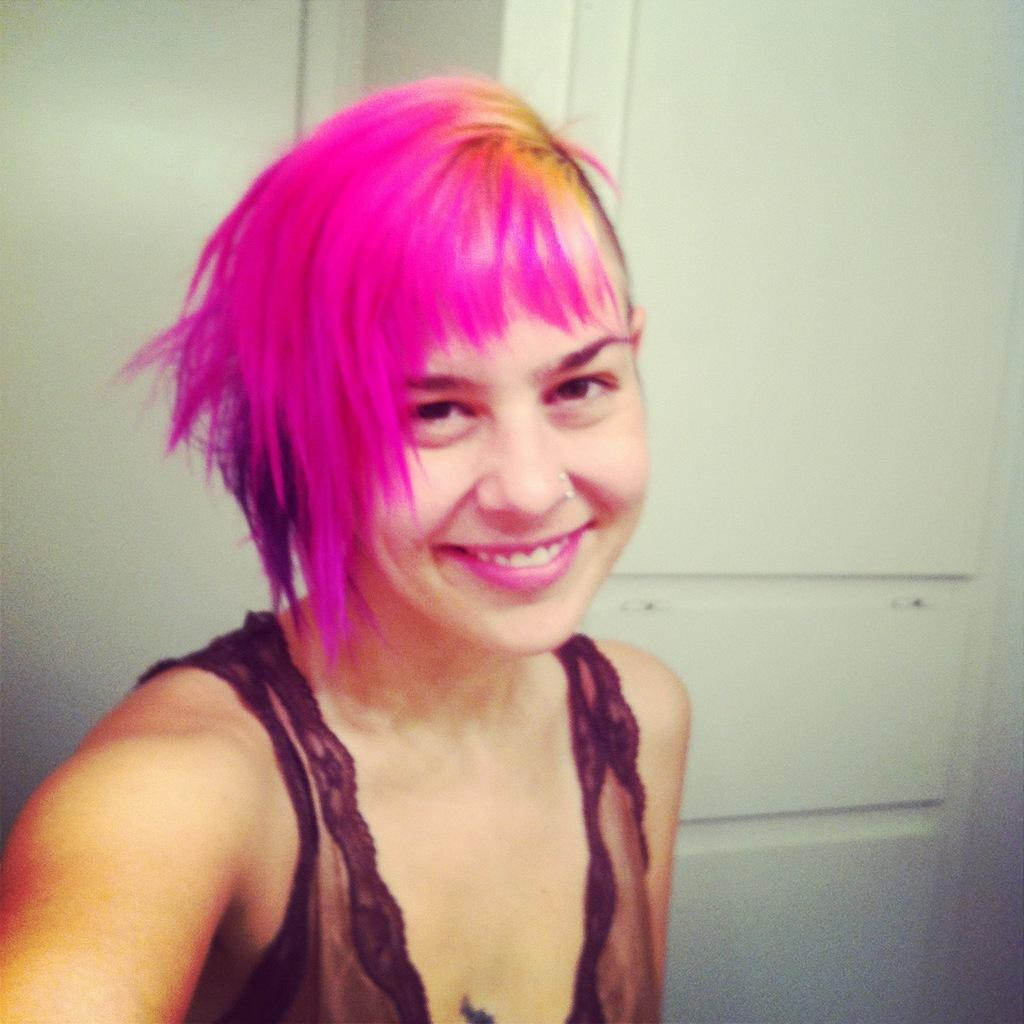Who is the main subject in the image? There is a girl in the image. What is the girl wearing? The girl is wearing clothes. What is the girl's facial expression in the image? The girl is smiling. What can be seen in the background of the image? There is a wall in the image. What is the color of the wall? The wall is white in color. What type of laborer is working on the wall in the image? There is no laborer present in the image, and the wall is not being worked on. How does the girl adjust her umbrella in the image? There is no umbrella present in the image, so no adjustment can be observed. 